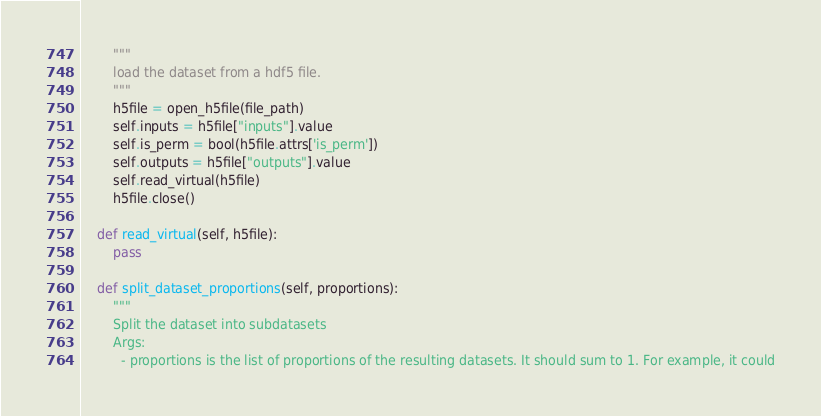<code> <loc_0><loc_0><loc_500><loc_500><_Python_>        """
        load the dataset from a hdf5 file.
        """
        h5file = open_h5file(file_path)
        self.inputs = h5file["inputs"].value
        self.is_perm = bool(h5file.attrs['is_perm'])
        self.outputs = h5file["outputs"].value
        self.read_virtual(h5file)
        h5file.close()

    def read_virtual(self, h5file):
        pass

    def split_dataset_proportions(self, proportions):
        """
        Split the dataset into subdatasets
        Args:
          - proportions is the list of proportions of the resulting datasets. It should sum to 1. For example, it could</code> 